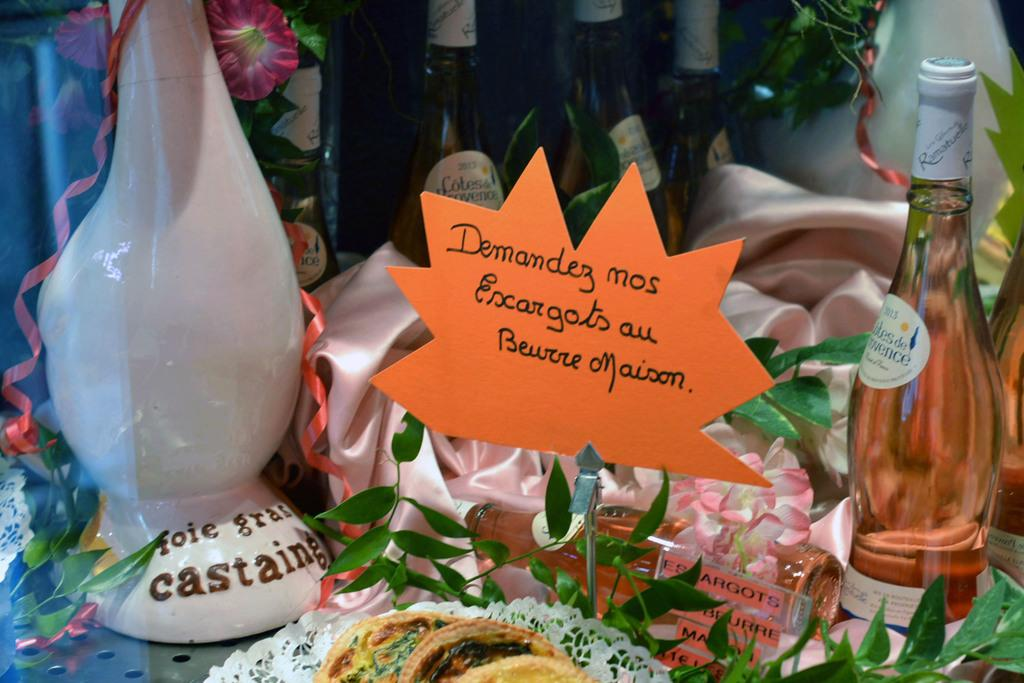<image>
Provide a brief description of the given image. A sign near several beverages says to ask for escargots au beurre maison. 